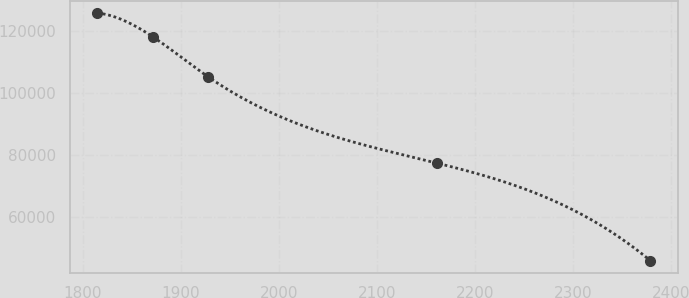Convert chart to OTSL. <chart><loc_0><loc_0><loc_500><loc_500><line_chart><ecel><fcel>Unnamed: 1<nl><fcel>1815<fcel>125628<nl><fcel>1871.37<fcel>118045<nl><fcel>1927.74<fcel>105193<nl><fcel>2161.07<fcel>77408.4<nl><fcel>2378.68<fcel>46067.6<nl></chart> 